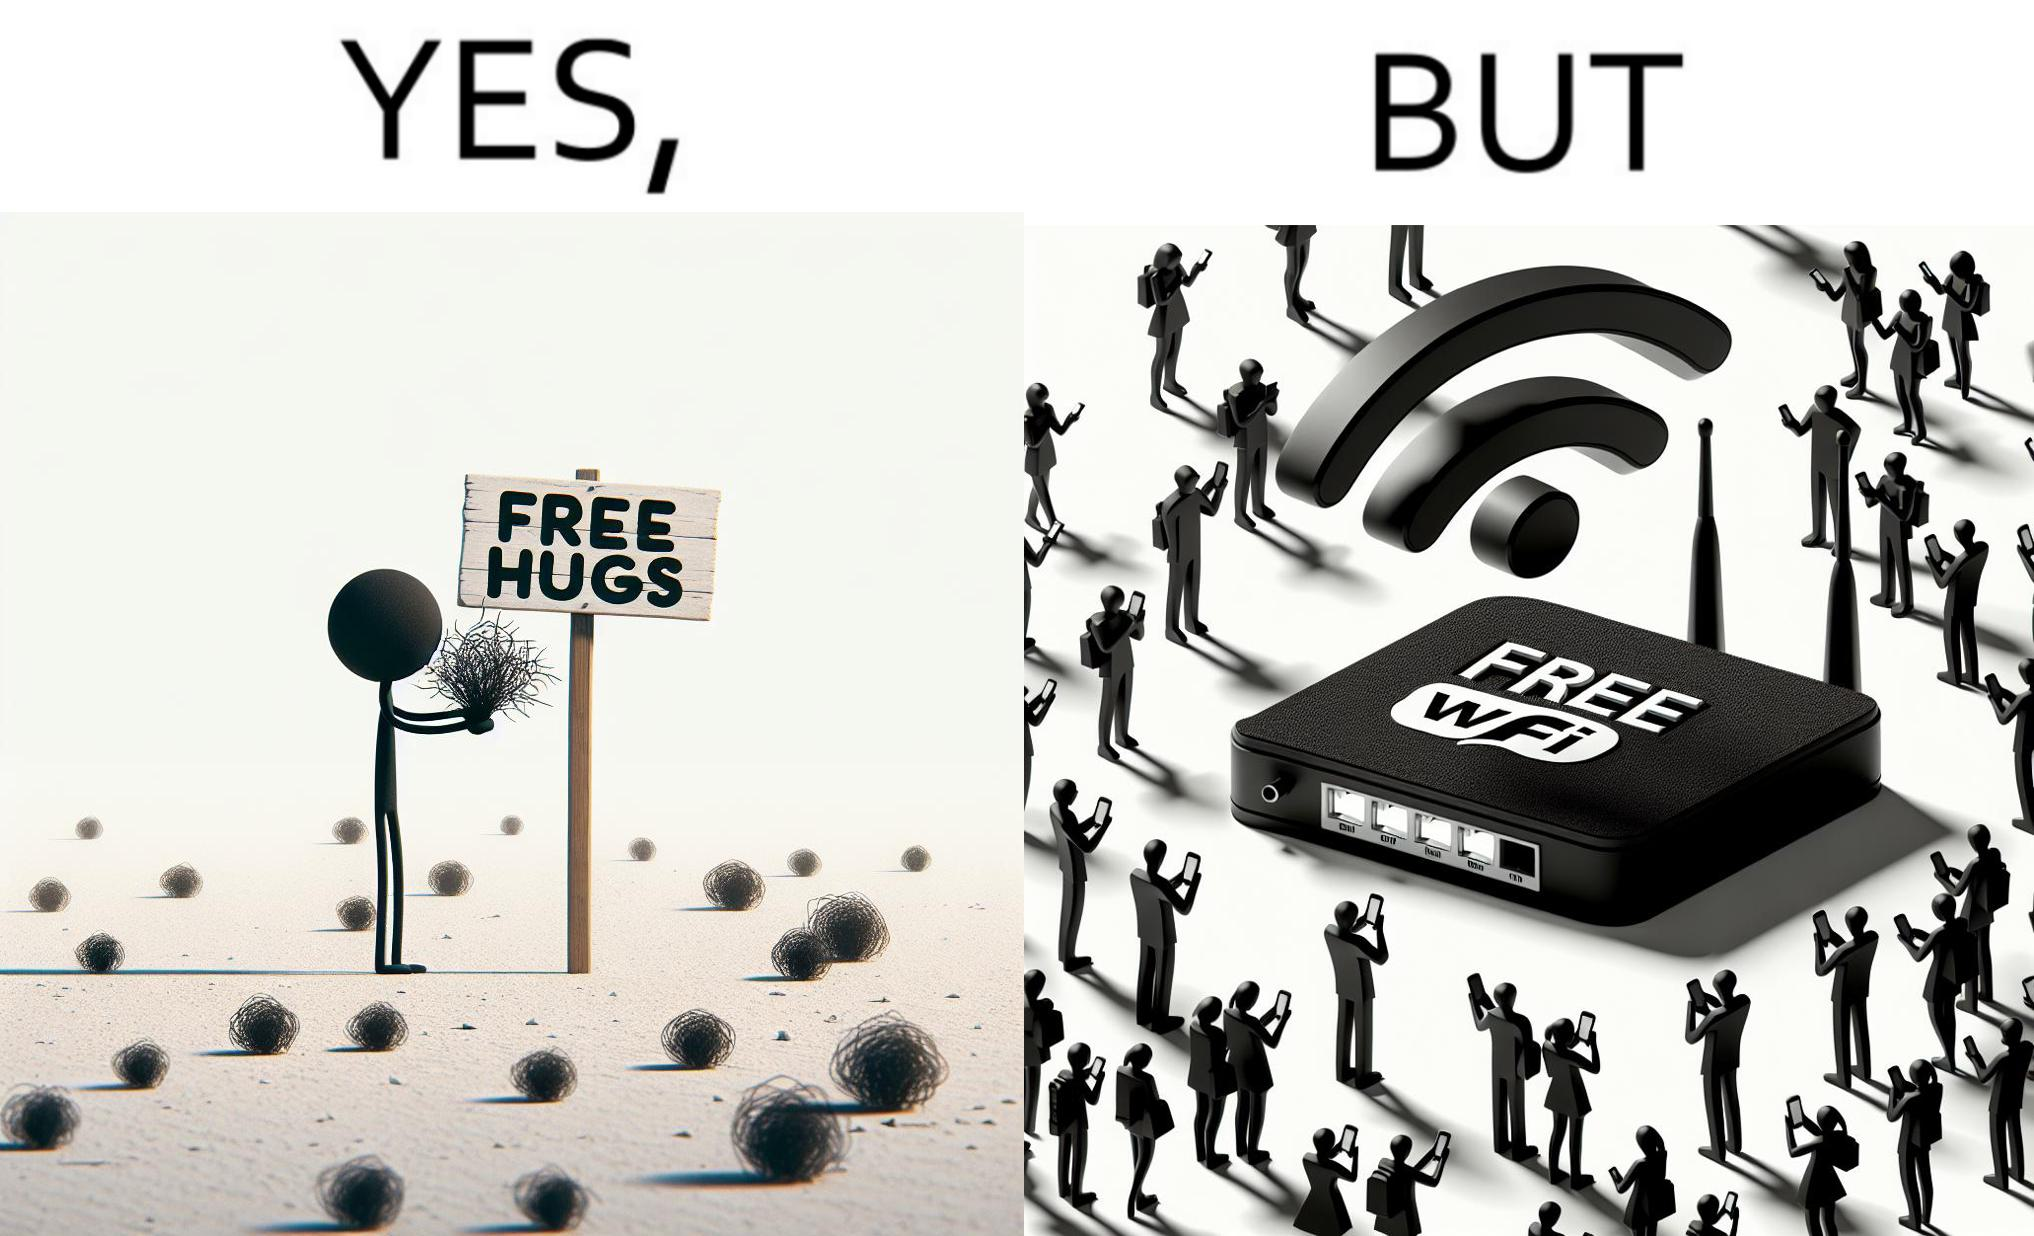What is shown in the left half versus the right half of this image? In the left part of the image: a person standing alone holding a sign "Free Hugs". The tumbleweeds blowing in the wind further stress on the loneliness. In the right part of the image: A Wi-fi Router with the label "Free Wifi" in front of it, surrounded by people trying to connect to it on their mobile devices. 